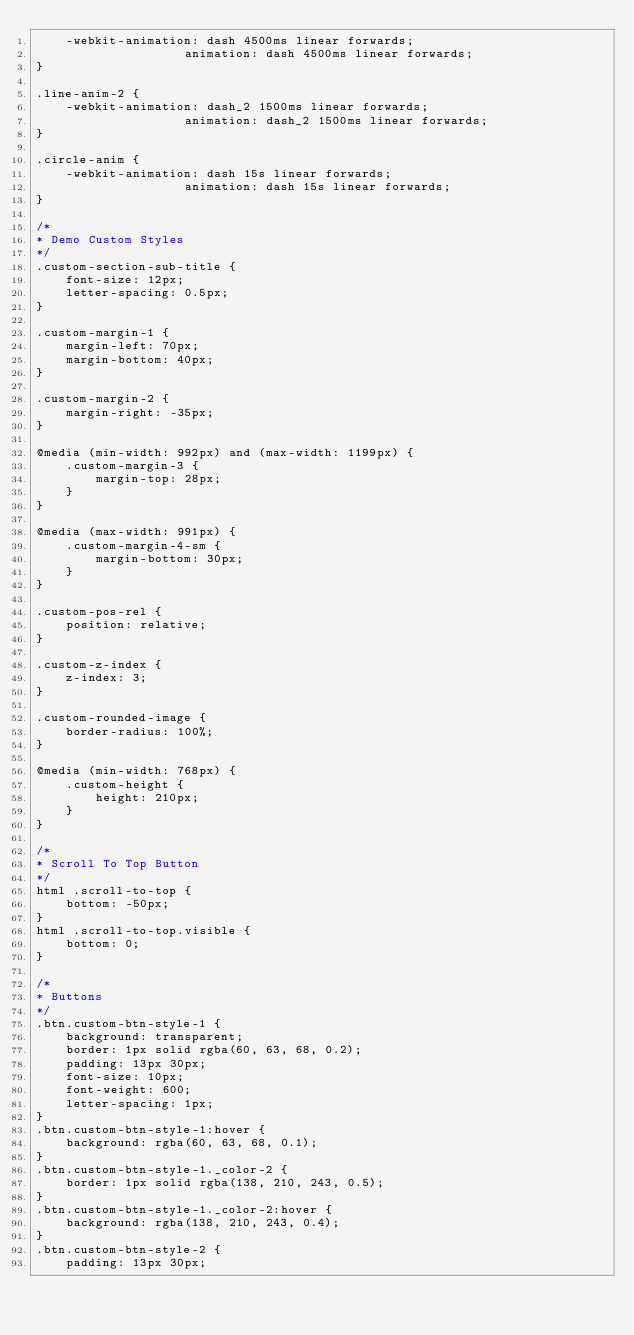<code> <loc_0><loc_0><loc_500><loc_500><_CSS_>	-webkit-animation: dash 4500ms linear forwards;
					animation: dash 4500ms linear forwards;
}

.line-anim-2 {
	-webkit-animation: dash_2 1500ms linear forwards;
					animation: dash_2 1500ms linear forwards;
}

.circle-anim {
	-webkit-animation: dash 15s linear forwards;
					animation: dash 15s linear forwards;
}

/*
* Demo Custom Styles
*/
.custom-section-sub-title {
	font-size: 12px;
	letter-spacing: 0.5px;
}

.custom-margin-1 {
	margin-left: 70px;
	margin-bottom: 40px;
}

.custom-margin-2 {
	margin-right: -35px;
}

@media (min-width: 992px) and (max-width: 1199px) {
	.custom-margin-3 {
		margin-top: 28px;
	}
}

@media (max-width: 991px) {
	.custom-margin-4-sm {
		margin-bottom: 30px;
	}
}

.custom-pos-rel {
	position: relative;
}

.custom-z-index {
	z-index: 3;
}

.custom-rounded-image {
	border-radius: 100%;
}

@media (min-width: 768px) {
	.custom-height {
		height: 210px;
	}
}

/*
* Scroll To Top Button
*/
html .scroll-to-top {
	bottom: -50px;
}
html .scroll-to-top.visible {
	bottom: 0;
}

/*
* Buttons
*/
.btn.custom-btn-style-1 {
	background: transparent;
	border: 1px solid rgba(60, 63, 68, 0.2);
	padding: 13px 30px;
	font-size: 10px;
	font-weight: 600;
	letter-spacing: 1px;
}
.btn.custom-btn-style-1:hover {
	background: rgba(60, 63, 68, 0.1);
}
.btn.custom-btn-style-1._color-2 {
	border: 1px solid rgba(138, 210, 243, 0.5);
}
.btn.custom-btn-style-1._color-2:hover {
	background: rgba(138, 210, 243, 0.4);
}
.btn.custom-btn-style-2 {
	padding: 13px 30px;</code> 